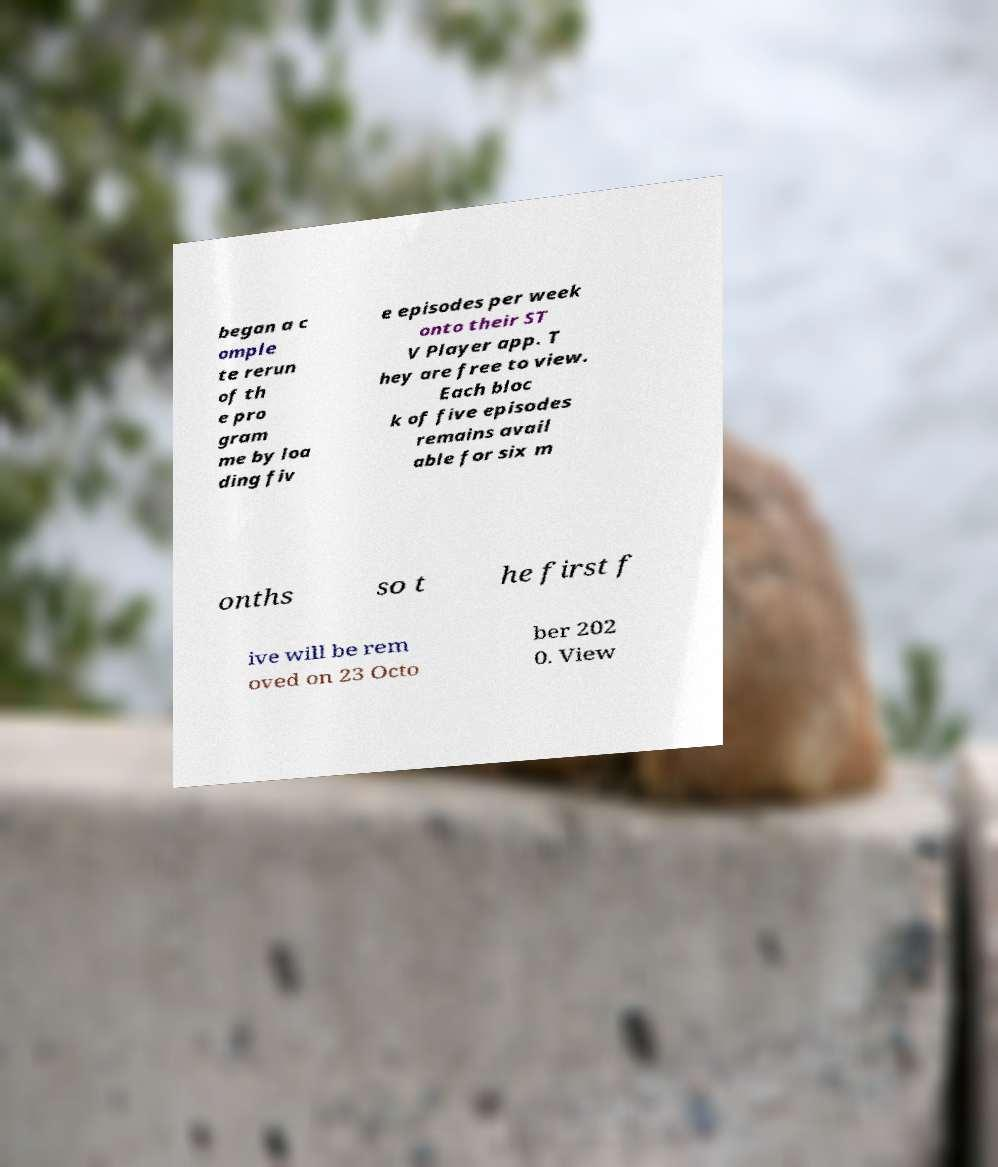Can you accurately transcribe the text from the provided image for me? began a c omple te rerun of th e pro gram me by loa ding fiv e episodes per week onto their ST V Player app. T hey are free to view. Each bloc k of five episodes remains avail able for six m onths so t he first f ive will be rem oved on 23 Octo ber 202 0. View 